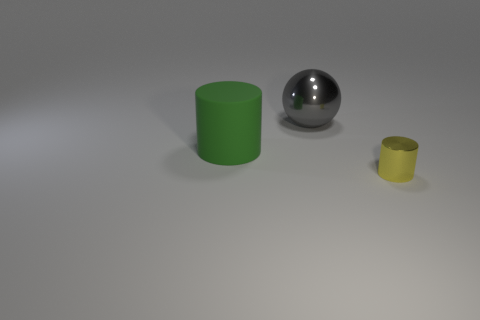What is the large object that is left of the large gray thing made of?
Give a very brief answer. Rubber. There is a small cylinder that is made of the same material as the large gray thing; what color is it?
Offer a terse response. Yellow. How many metallic things have the same size as the gray metal ball?
Give a very brief answer. 0. There is a shiny thing behind the green rubber cylinder; does it have the same size as the large matte object?
Your answer should be compact. Yes. There is a object that is in front of the gray thing and to the left of the yellow shiny object; what shape is it?
Your answer should be very brief. Cylinder. Are there any objects in front of the gray ball?
Provide a succinct answer. Yes. Is there anything else that is the same shape as the gray object?
Your response must be concise. No. Do the small metal thing and the green rubber thing have the same shape?
Offer a terse response. Yes. Is the number of big metal spheres that are in front of the shiny cylinder the same as the number of tiny metal cylinders to the right of the big gray object?
Provide a short and direct response. No. What number of other objects are the same material as the large sphere?
Make the answer very short. 1. 